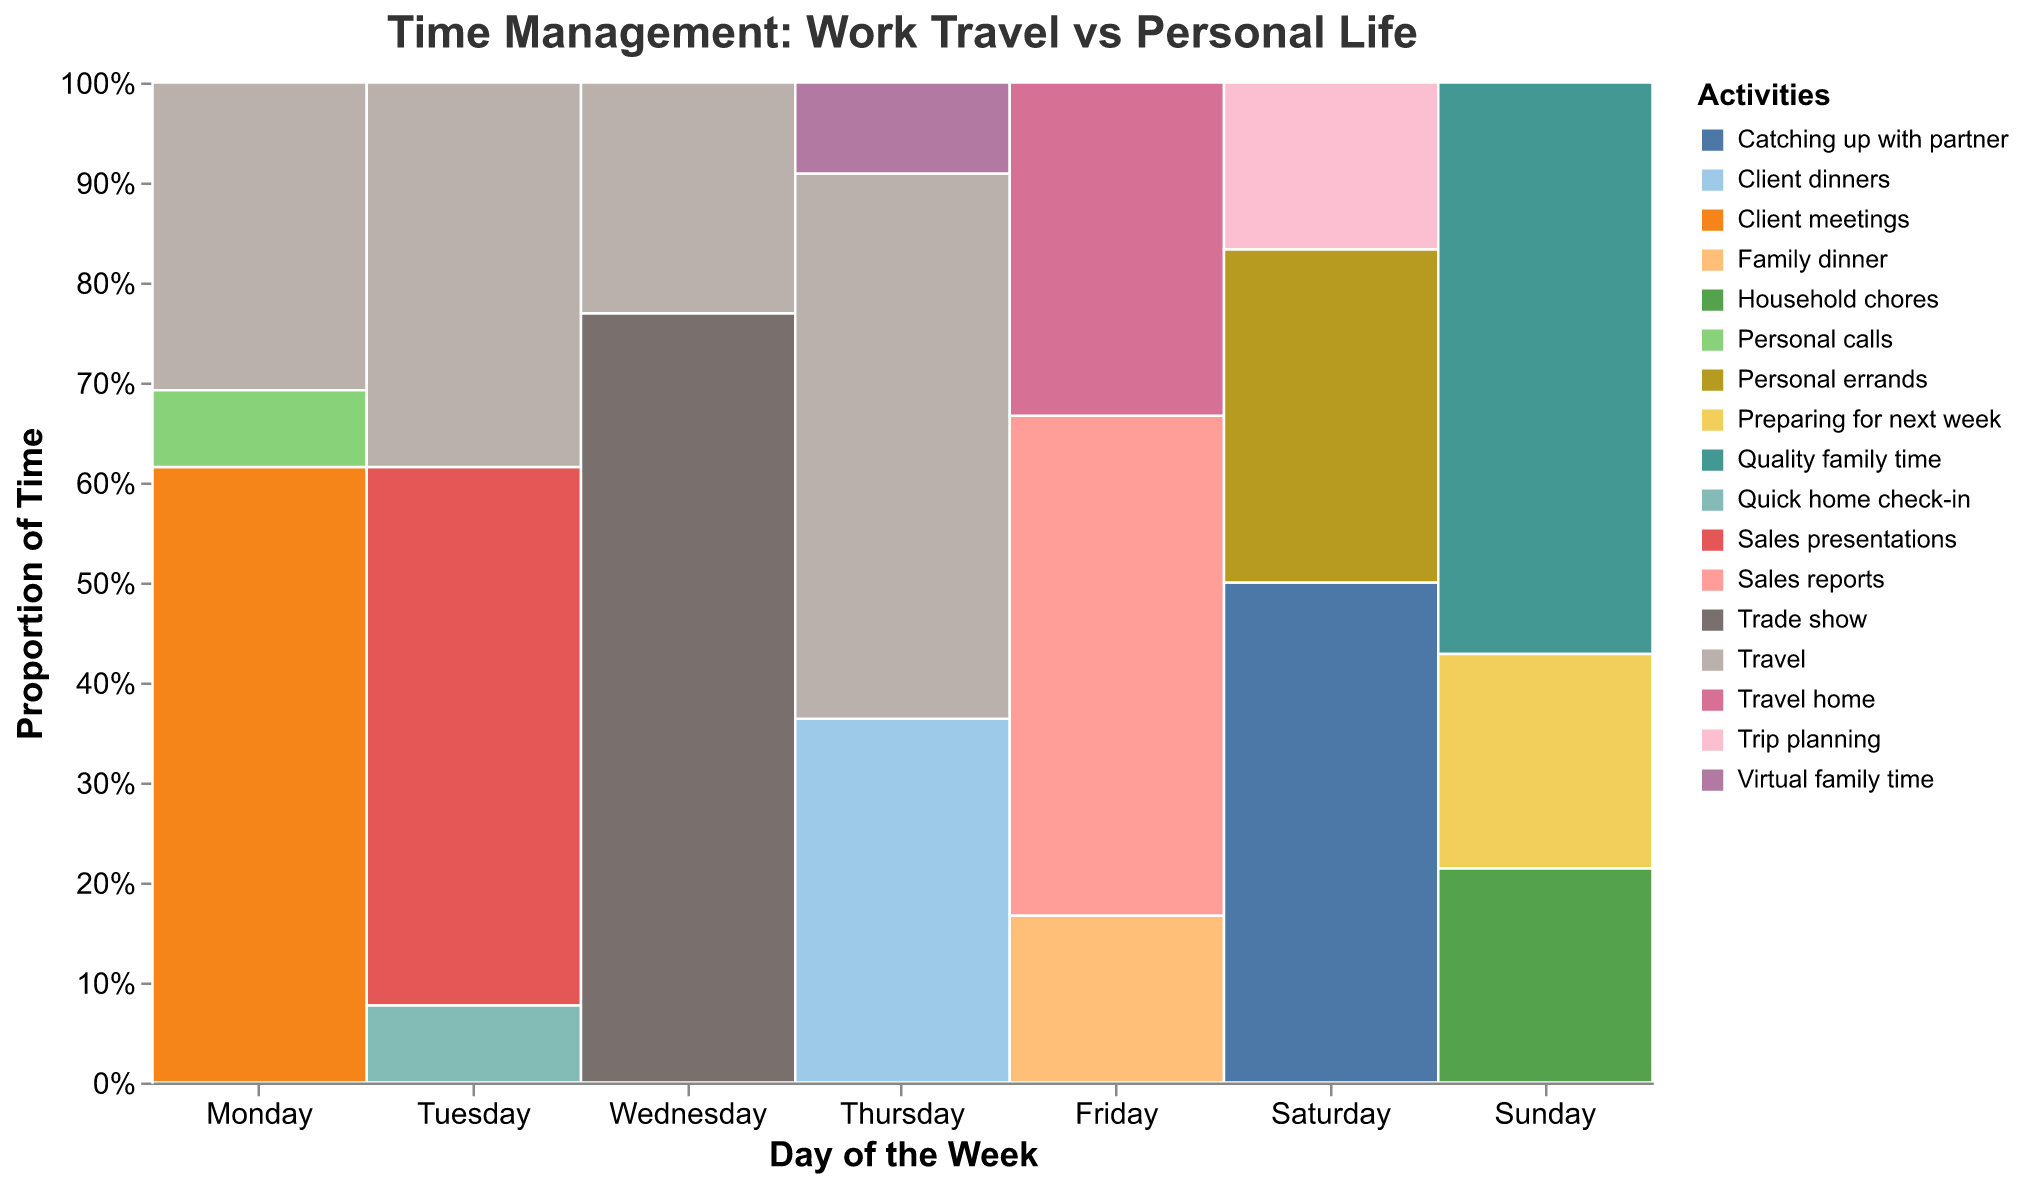How is the time distributed across different activities on Monday? On Monday, Client meetings take the most time with 8 hours, followed by Travel with 4 hours, and then Personal calls with 1 hour.
Answer: Client meetings: 8 hours, Travel: 4 hours, Personal calls: 1 hour Which day involves the most travel time? Refer to each entry of "Travel" per day and sum the hours. Thursday has 6 hours of travel, which is the highest.
Answer: Thursday How does the time spent on family-related activities compare between weekdays and weekends? For weekdays, family-related activities include "Virtual family time" (1 hour on Thursday) and "Family dinner" (2 hours on Friday), totaling 3 hours. On weekends, "Catching up with partner" (6 hours on Saturday) and "Quality family time" (8 hours on Sunday) and "Household chores" (3 hours on Sunday), totaling 17 hours.
Answer: Weekdays: 3 hours, Weekends: 17 hours What proportion of Sunday is dedicated to preparing for the next week? According to the plot, 3 hours on Sunday are allocated for preparing for next week, and the total for Sunday is 14 hours. The proportion is calculated as 3/14.
Answer: Approximately 21.4% Which activity occupies the most hours over the entire week? Summing up the hours for each activity across all days, "Travel" occupies the most time, with a total of (4+5+3+6+4) = 22 hours.
Answer: Travel: 22 hours On which day is the least amount of time spent on work-related activities? Weekends (Saturday and Sunday) have no traditional work-related activities like client meetings or sales but have personal and family-related activities instead.
Answer: Saturday and Sunday How does the time spent on personal errands change from weekdays to weekends? Weekdays (Monday to Friday) do not list personal errands, while Saturday has 4 hours for personal errands.
Answer: 4 hours on weekends, none on weekdays Is the time spent on sales presentations or trade shows consistent throughout the week? Sales presentations occur on Tuesday (7 hours) and Trade show on Wednesday (10 hours). These activities do not repeat on other days.
Answer: No, it's not consistent What is the combined total time spent on client interactions (meetings, dinners) throughout the week? Summing client interactions: Client meetings (8 hours on Monday), Client dinners (4 hours on Thursday) total (8+4) = 12 hours.
Answer: 12 hours On which day is the highest proportion of the day spent on non-professional (personal/family) activities? Identify non-professional activities: For Sunday, Quality family time (8 hours), Household chores (3 hours), Preparing for next week (3 hours). Total is 14 hours. The highest proportion day is Sunday with 100%.
Answer: Sunday 